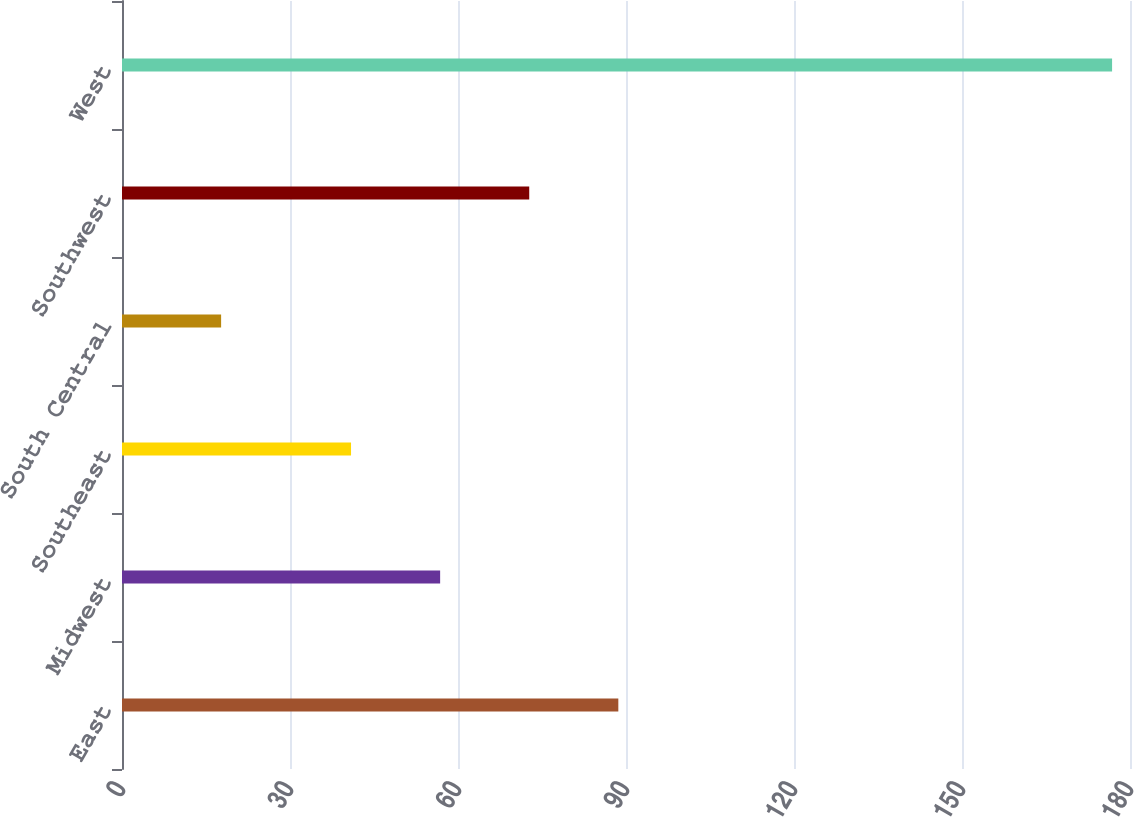Convert chart. <chart><loc_0><loc_0><loc_500><loc_500><bar_chart><fcel>East<fcel>Midwest<fcel>Southeast<fcel>South Central<fcel>Southwest<fcel>West<nl><fcel>88.63<fcel>56.81<fcel>40.9<fcel>17.7<fcel>72.72<fcel>176.8<nl></chart> 